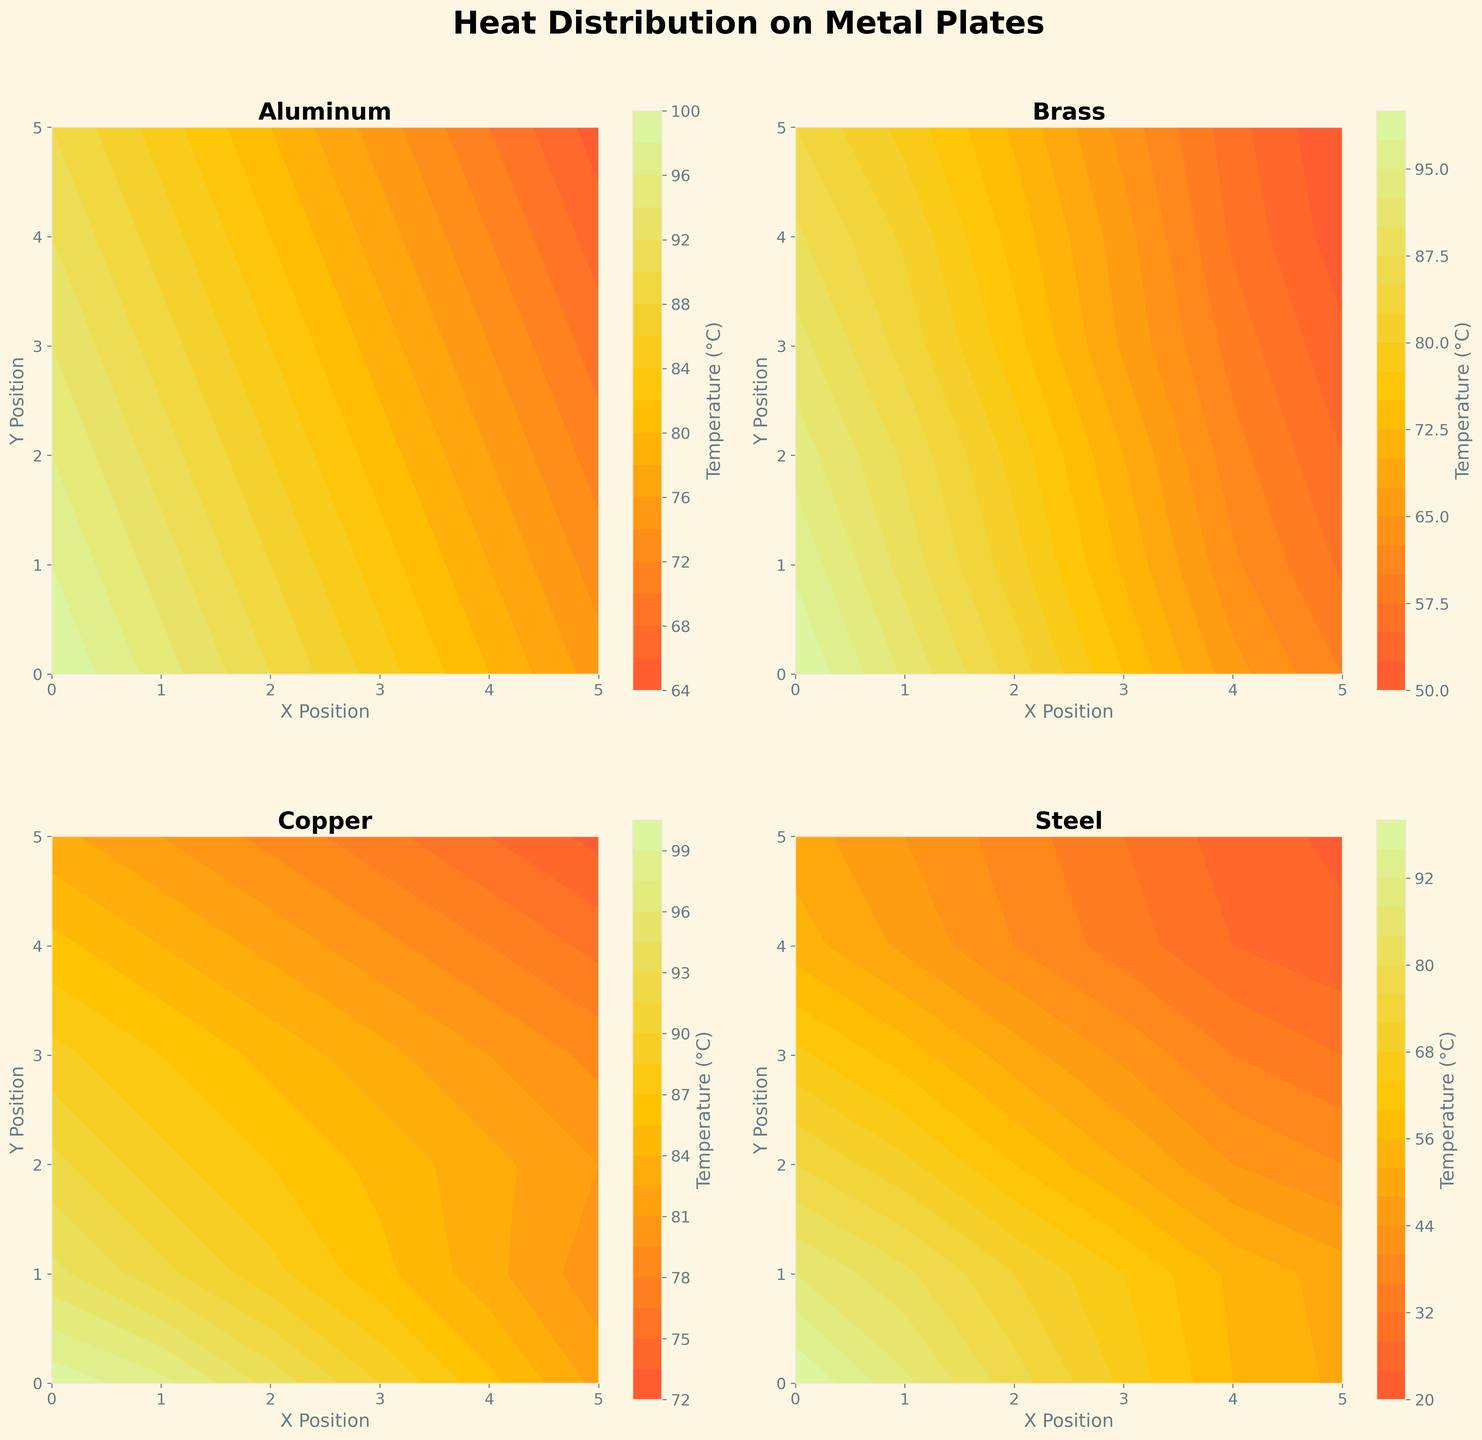How many different materials are represented in the contour plots? The figure presents four different contour plots, each corresponding to a different material. The titles of the subplots indicate the materials.
Answer: Four Which material shows the highest temperature near the upper left (X=0, Y=0) corner? By looking at the upper-left corner (X=0, Y=0) across all four contour plots, we observe that all plots start at 100°C in this corner.
Answer: All materials What is the general trend of temperature distribution for Aluminum from left to right along the X-axis at Y=0? Observing the subplot of Aluminum, we see that the temperature decreases from 100°C at X=0 to 75°C at X=5.
Answer: Decreasing Is the heat distribution in Steel more uniform or does it have a steep gradient? From the contour plot of Steel, particularly the gradation lines, we observe a steep gradient, indicating rapid temperature drops.
Answer: Steep gradient What are the temperature values at the center (X=2, Y=2) for Brass and Copper, and which one is higher? Checking the contour plots of Brass and Copper at the center point (X=2, Y=2), Brass shows a temperature of approximately 79°C, while Copper shows about 87°C. Comparatively, Copper has a higher value.
Answer: Copper Compare the temperature at the bottom right (X=5, Y=5) among all materials. Which one has the lowest temperature? The bottom-right corner value is as follows: Aluminum: 65°C, Brass: 50°C, Copper: 73°C, Steel: 23°C. Among them, Steel has the lowest temperature.
Answer: Steel Does Copper exhibit a higher temperature than Steel at point (X=3, Y=3)? If so, by how much? Referring to the contour plots for Copper and Steel, at (X=3, Y=3), Copper is 83°C and Steel is 43°C, so the difference is 83°C - 43°C = 40°C.
Answer: 40°C Which material maintains the highest temperature range across the entire plate? Examining the full range from highest to lowest temperatures in each plot, Copper consistently shows higher temperatures than the others.
Answer: Copper How does the temperature of Brass change as you move from point A (X=1, Y=1) to point B (X=4, Y=4)? For Brass, the temperature at (X=1, Y=1) is about 89°C, while at (X=4, Y=4), it is approximately 57°C. Hence, moving from A to B, the temperature decreases by 32°C.
Answer: Decreases by 32°C Between Aluminum and Steel, which material has a more significant temperature decrease from the center (X=2, Y=2) to the bottom right (X=5, Y=5)? For Aluminum, at the center, the temperature is about 86°C and at the bottom right it is 65°C, a decrease of 21°C. For Steel, at the center, it is around 40°C and at the bottom right it is 23°C, a decrease of 17°C. Thus, Aluminum experiences a more significant decrease.
Answer: Aluminum 